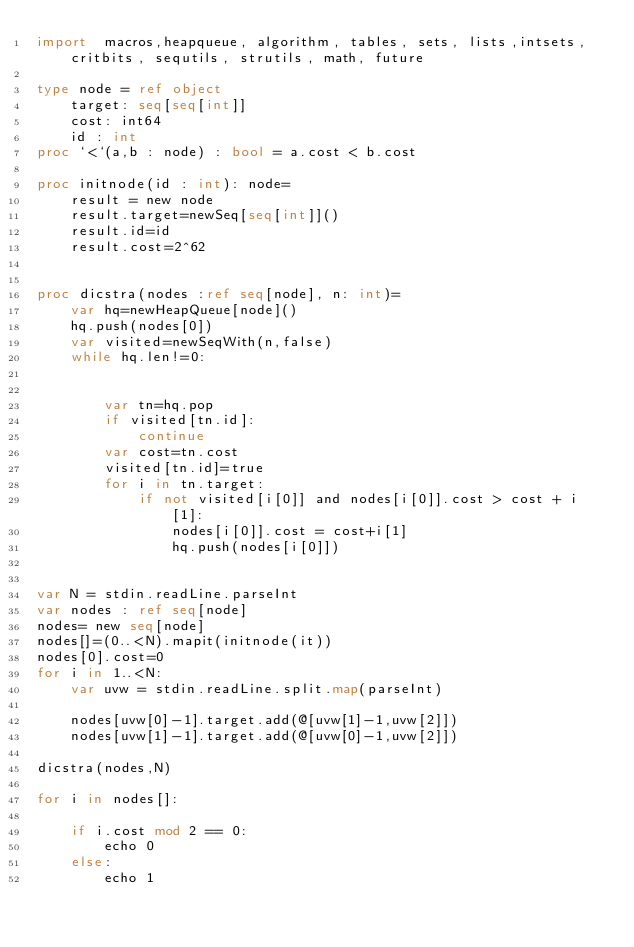<code> <loc_0><loc_0><loc_500><loc_500><_Nim_>import  macros,heapqueue, algorithm, tables, sets, lists,intsets, critbits, sequtils, strutils, math, future

type node = ref object
    target: seq[seq[int]]
    cost: int64
    id : int
proc `<`(a,b : node) : bool = a.cost < b.cost

proc initnode(id : int): node=
    result = new node
    result.target=newSeq[seq[int]]()
    result.id=id
    result.cost=2^62


proc dicstra(nodes :ref seq[node], n: int)=
    var hq=newHeapQueue[node]()
    hq.push(nodes[0])
    var visited=newSeqWith(n,false)
    while hq.len!=0:

            
        var tn=hq.pop
        if visited[tn.id]:
            continue
        var cost=tn.cost
        visited[tn.id]=true
        for i in tn.target:
            if not visited[i[0]] and nodes[i[0]].cost > cost + i[1]:
                nodes[i[0]].cost = cost+i[1]
                hq.push(nodes[i[0]])            


var N = stdin.readLine.parseInt
var nodes : ref seq[node]
nodes= new seq[node]
nodes[]=(0..<N).mapit(initnode(it))
nodes[0].cost=0
for i in 1..<N:
    var uvw = stdin.readLine.split.map(parseInt)

    nodes[uvw[0]-1].target.add(@[uvw[1]-1,uvw[2]])
    nodes[uvw[1]-1].target.add(@[uvw[0]-1,uvw[2]])

dicstra(nodes,N)

for i in nodes[]:

    if i.cost mod 2 == 0:
        echo 0
    else:
        echo 1







</code> 